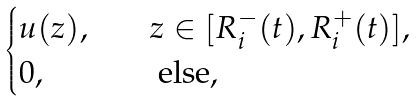Convert formula to latex. <formula><loc_0><loc_0><loc_500><loc_500>\begin{cases} u ( z ) , & \quad z \in [ R _ { i } ^ { - } ( t ) , R _ { i } ^ { + } ( t ) ] , \\ 0 , & \quad \text { else,} \end{cases}</formula> 